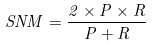Convert formula to latex. <formula><loc_0><loc_0><loc_500><loc_500>S N M = \frac { 2 \times P \times R } { P + R }</formula> 